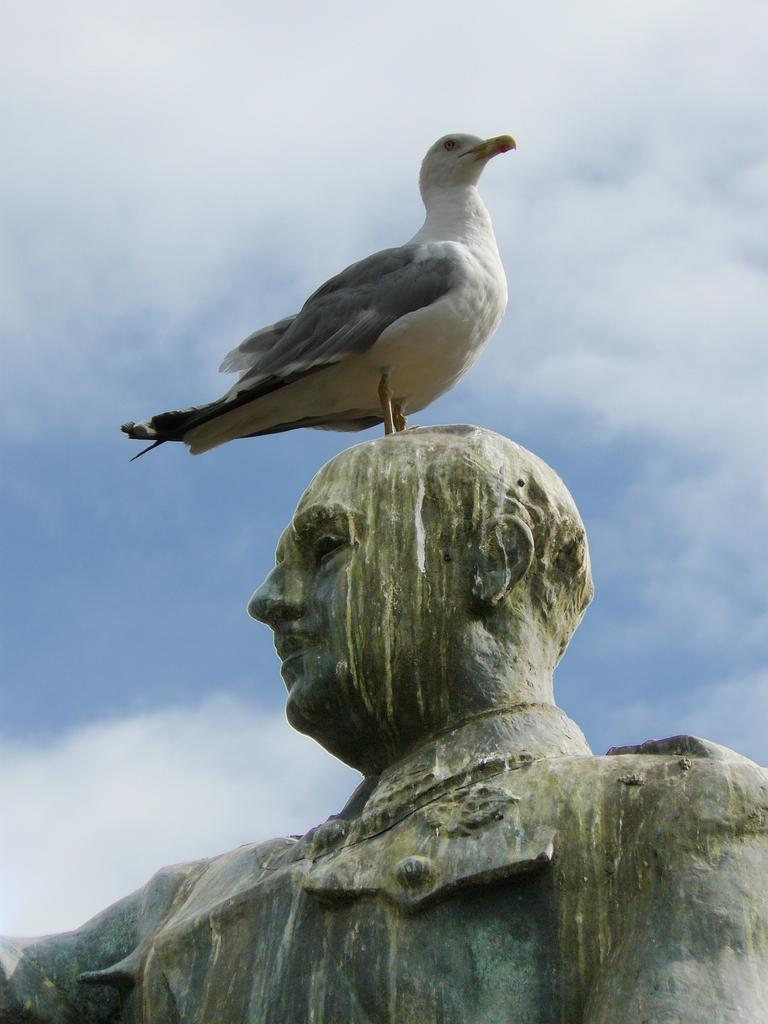What is the main subject in the foreground of the image? There is a statue in the foreground of the image. What other subject can be seen in the middle of the image? There is a bird in the middle of the image. What is visible at the top of the image? The sky is visible at the top of the image. What type of board is being used by the bird in the image? There is no board present in the image; it features a statue and a bird. What type of cloth is draped over the statue in the image? There is no cloth draped over the statue in the image; it is a standalone statue. 